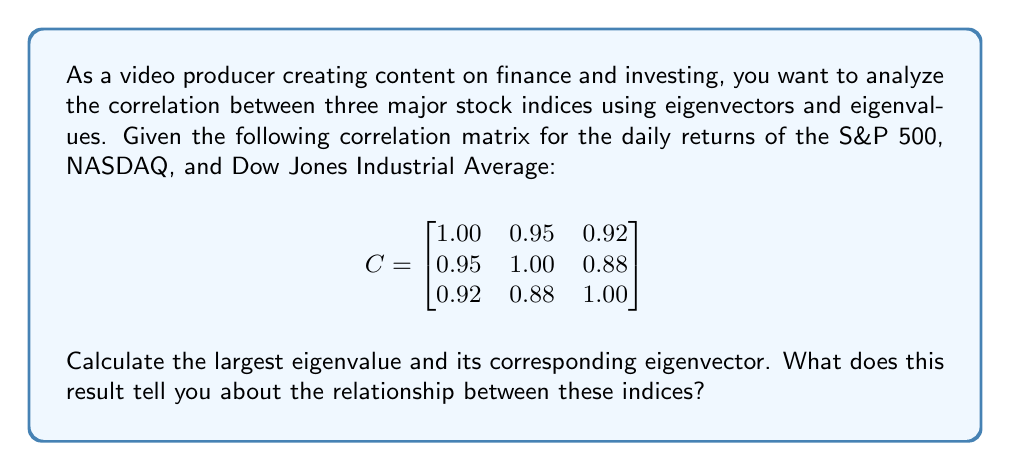What is the answer to this math problem? To solve this problem, we'll follow these steps:

1) First, we need to find the characteristic equation of the matrix C:
   $$det(C - \lambda I) = 0$$

2) Expand the determinant:
   $$\begin{vmatrix}
   1.00 - \lambda & 0.95 & 0.92 \\
   0.95 & 1.00 - \lambda & 0.88 \\
   0.92 & 0.88 & 1.00 - \lambda
   \end{vmatrix} = 0$$

3) This gives us the cubic equation:
   $$-\lambda^3 + 3\lambda^2 - 0.4126\lambda + 0.0109 = 0$$

4) Solving this equation (using a calculator or computer algebra system) gives us the eigenvalues:
   $$\lambda_1 \approx 2.8361, \lambda_2 \approx 0.1372, \lambda_3 \approx 0.0267$$

5) The largest eigenvalue is $\lambda_1 \approx 2.8361$.

6) To find the corresponding eigenvector, we solve:
   $$(C - \lambda_1 I)v = 0$$

7) This gives us the system of equations:
   $$\begin{aligned}
   -1.8361v_1 + 0.95v_2 + 0.92v_3 &= 0 \\
   0.95v_1 - 1.8361v_2 + 0.88v_3 &= 0 \\
   0.92v_1 + 0.88v_2 - 1.8361v_3 &= 0
   \end{aligned}$$

8) Solving this system (and normalizing the result) gives us the eigenvector:
   $$v_1 \approx \begin{bmatrix} 0.5816 \\ 0.5774 \\ 0.5730 \end{bmatrix}$$

Interpretation: The largest eigenvalue (2.8361) represents the direction of maximum variance in the data. Its corresponding eigenvector shows the weights of each index in this principal component. The fact that all components of this eigenvector are positive and similar in magnitude (about 0.58) indicates that all three indices move together strongly. This is consistent with the high correlations in the original matrix. The S&P 500 has a slightly higher weight, followed closely by NASDAQ and then the Dow Jones Industrial Average.
Answer: The largest eigenvalue is approximately 2.8361, and its corresponding normalized eigenvector is approximately [0.5816, 0.5774, 0.5730]. This indicates strong positive correlation among all three indices, with the S&P 500 having a slightly stronger influence in the overall market movement. 